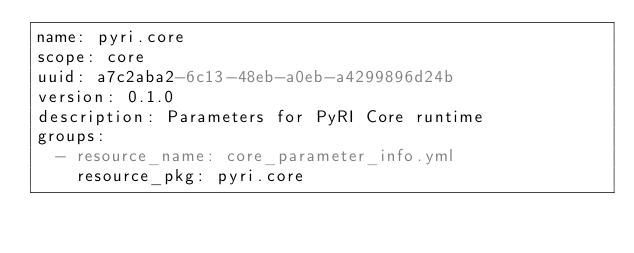Convert code to text. <code><loc_0><loc_0><loc_500><loc_500><_YAML_>name: pyri.core
scope: core
uuid: a7c2aba2-6c13-48eb-a0eb-a4299896d24b
version: 0.1.0
description: Parameters for PyRI Core runtime
groups:
  - resource_name: core_parameter_info.yml
    resource_pkg: pyri.core</code> 